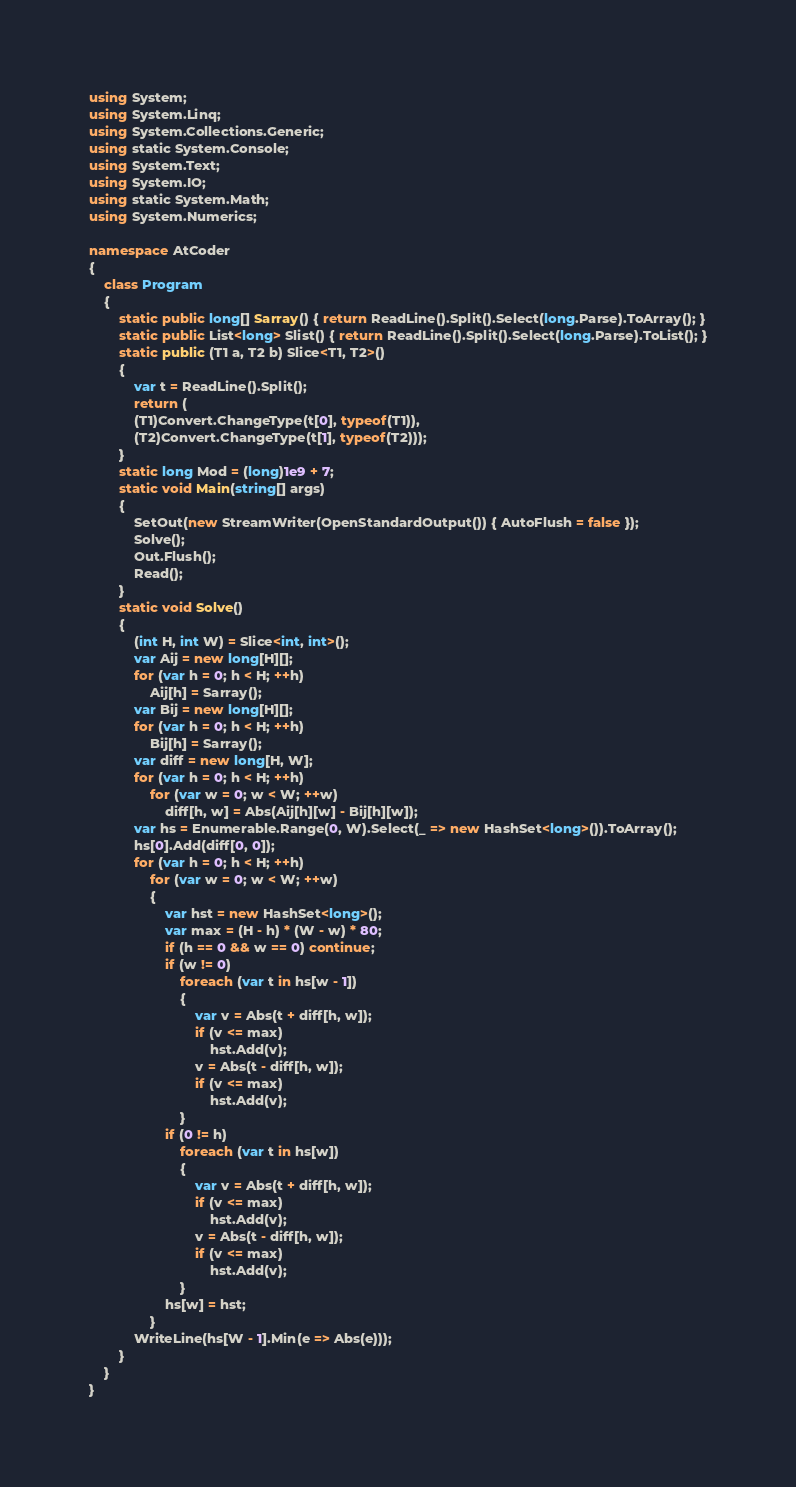Convert code to text. <code><loc_0><loc_0><loc_500><loc_500><_C#_>using System;
using System.Linq;
using System.Collections.Generic;
using static System.Console;
using System.Text;
using System.IO;
using static System.Math;
using System.Numerics;

namespace AtCoder
{
    class Program
    {
        static public long[] Sarray() { return ReadLine().Split().Select(long.Parse).ToArray(); }
        static public List<long> Slist() { return ReadLine().Split().Select(long.Parse).ToList(); }
        static public (T1 a, T2 b) Slice<T1, T2>()
        {
            var t = ReadLine().Split();
            return (
            (T1)Convert.ChangeType(t[0], typeof(T1)),
            (T2)Convert.ChangeType(t[1], typeof(T2)));
        }
        static long Mod = (long)1e9 + 7;
        static void Main(string[] args)
        {
            SetOut(new StreamWriter(OpenStandardOutput()) { AutoFlush = false });
            Solve();
            Out.Flush();
            Read();
        }
        static void Solve()
        {
            (int H, int W) = Slice<int, int>();
            var Aij = new long[H][];
            for (var h = 0; h < H; ++h)
                Aij[h] = Sarray();
            var Bij = new long[H][];
            for (var h = 0; h < H; ++h)
                Bij[h] = Sarray();
            var diff = new long[H, W];
            for (var h = 0; h < H; ++h)
                for (var w = 0; w < W; ++w)
                    diff[h, w] = Abs(Aij[h][w] - Bij[h][w]);
            var hs = Enumerable.Range(0, W).Select(_ => new HashSet<long>()).ToArray();
            hs[0].Add(diff[0, 0]);
            for (var h = 0; h < H; ++h)
                for (var w = 0; w < W; ++w)
                {
                    var hst = new HashSet<long>();
                    var max = (H - h) * (W - w) * 80;
                    if (h == 0 && w == 0) continue;
                    if (w != 0)
                        foreach (var t in hs[w - 1])
                        {
                            var v = Abs(t + diff[h, w]);
                            if (v <= max)
                                hst.Add(v);
                            v = Abs(t - diff[h, w]);
                            if (v <= max)
                                hst.Add(v);
                        }
                    if (0 != h)
                        foreach (var t in hs[w])
                        {
                            var v = Abs(t + diff[h, w]);
                            if (v <= max)
                                hst.Add(v);
                            v = Abs(t - diff[h, w]);
                            if (v <= max)
                                hst.Add(v);
                        }
                    hs[w] = hst;
                }
            WriteLine(hs[W - 1].Min(e => Abs(e)));
        }
    }
}</code> 